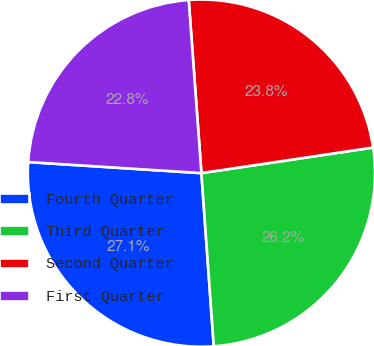<chart> <loc_0><loc_0><loc_500><loc_500><pie_chart><fcel>Fourth Quarter<fcel>Third Quarter<fcel>Second Quarter<fcel>First Quarter<nl><fcel>27.15%<fcel>26.22%<fcel>23.81%<fcel>22.82%<nl></chart> 